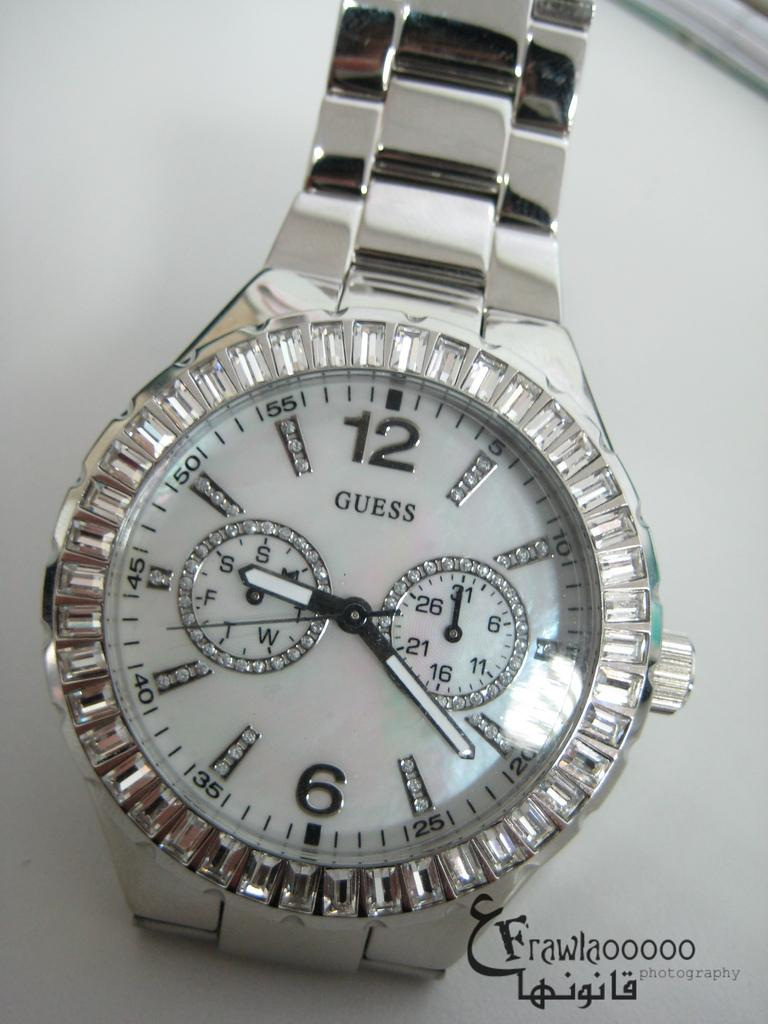<image>
Write a terse but informative summary of the picture. A Guess watch is on display on a counter. 